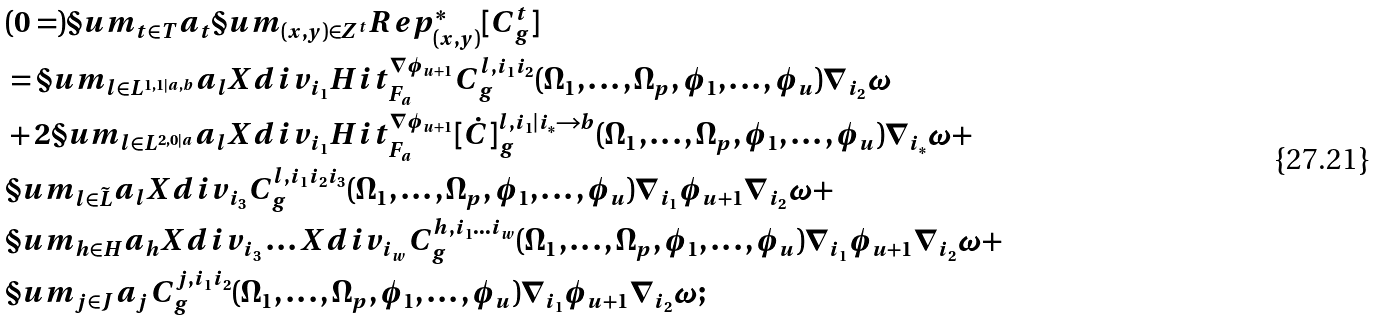<formula> <loc_0><loc_0><loc_500><loc_500>& ( 0 = ) \S u m _ { t \in T } a _ { t } \S u m _ { ( x , y ) \in Z ^ { t } } R e p ^ { * } _ { ( x , y ) } [ C ^ { t } _ { g } ] \\ & = \S u m _ { l \in L ^ { 1 , 1 | a , b } } a _ { l } X d i v _ { i _ { 1 } } H i t ^ { \nabla \phi _ { u + 1 } } _ { F _ { a } } C ^ { l , i _ { 1 } i _ { 2 } } _ { g } ( \Omega _ { 1 } , \dots , \Omega _ { p } , \phi _ { 1 } , \dots , \phi _ { u } ) \nabla _ { i _ { 2 } } \omega \\ & + 2 \S u m _ { l \in L ^ { 2 , 0 | a } } a _ { l } X d i v _ { i _ { 1 } } H i t ^ { \nabla \phi _ { u + 1 } } _ { F _ { a } } [ \dot { C } ] ^ { l , i _ { 1 } | i _ { * } \rightarrow b } _ { g } ( \Omega _ { 1 } , \dots , \Omega _ { p } , \phi _ { 1 } , \dots , \phi _ { u } ) \nabla _ { i _ { * } } \omega + \\ & \S u m _ { l \in \tilde { L } } a _ { l } X d i v _ { i _ { 3 } } C ^ { l , i _ { 1 } i _ { 2 } i _ { 3 } } _ { g } ( \Omega _ { 1 } , \dots , \Omega _ { p } , \phi _ { 1 } , \dots , \phi _ { u } ) \nabla _ { i _ { 1 } } \phi _ { u + 1 } \nabla _ { i _ { 2 } } \omega + \\ & \S u m _ { h \in H } a _ { h } X d i v _ { i _ { 3 } } \dots X d i v _ { i _ { w } } C ^ { h , i _ { 1 } \dots i _ { w } } _ { g } ( \Omega _ { 1 } , \dots , \Omega _ { p } , \phi _ { 1 } , \dots , \phi _ { u } ) \nabla _ { i _ { 1 } } \phi _ { u + 1 } \nabla _ { i _ { 2 } } \omega + \\ & \S u m _ { j \in J } a _ { j } C ^ { j , i _ { 1 } i _ { 2 } } _ { g } ( \Omega _ { 1 } , \dots , \Omega _ { p } , \phi _ { 1 } , \dots , \phi _ { u } ) \nabla _ { i _ { 1 } } \phi _ { u + 1 } \nabla _ { i _ { 2 } } \omega ;</formula> 